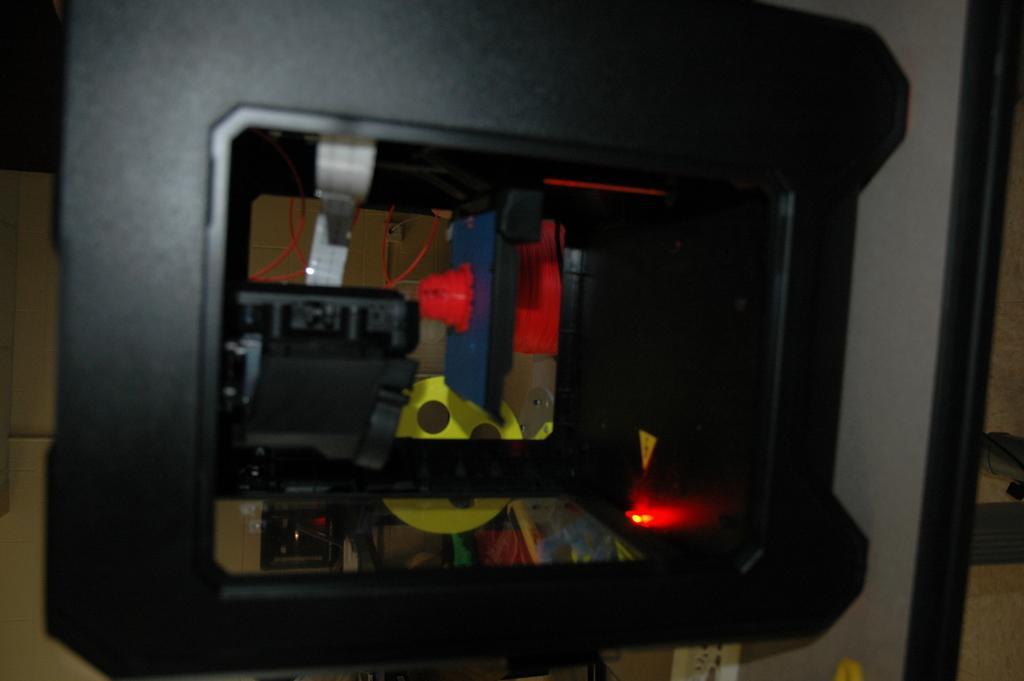Describe this image in one or two sentences. In this picture in the center there is an object which is black in colour and inside the object there is light and there are wires. 